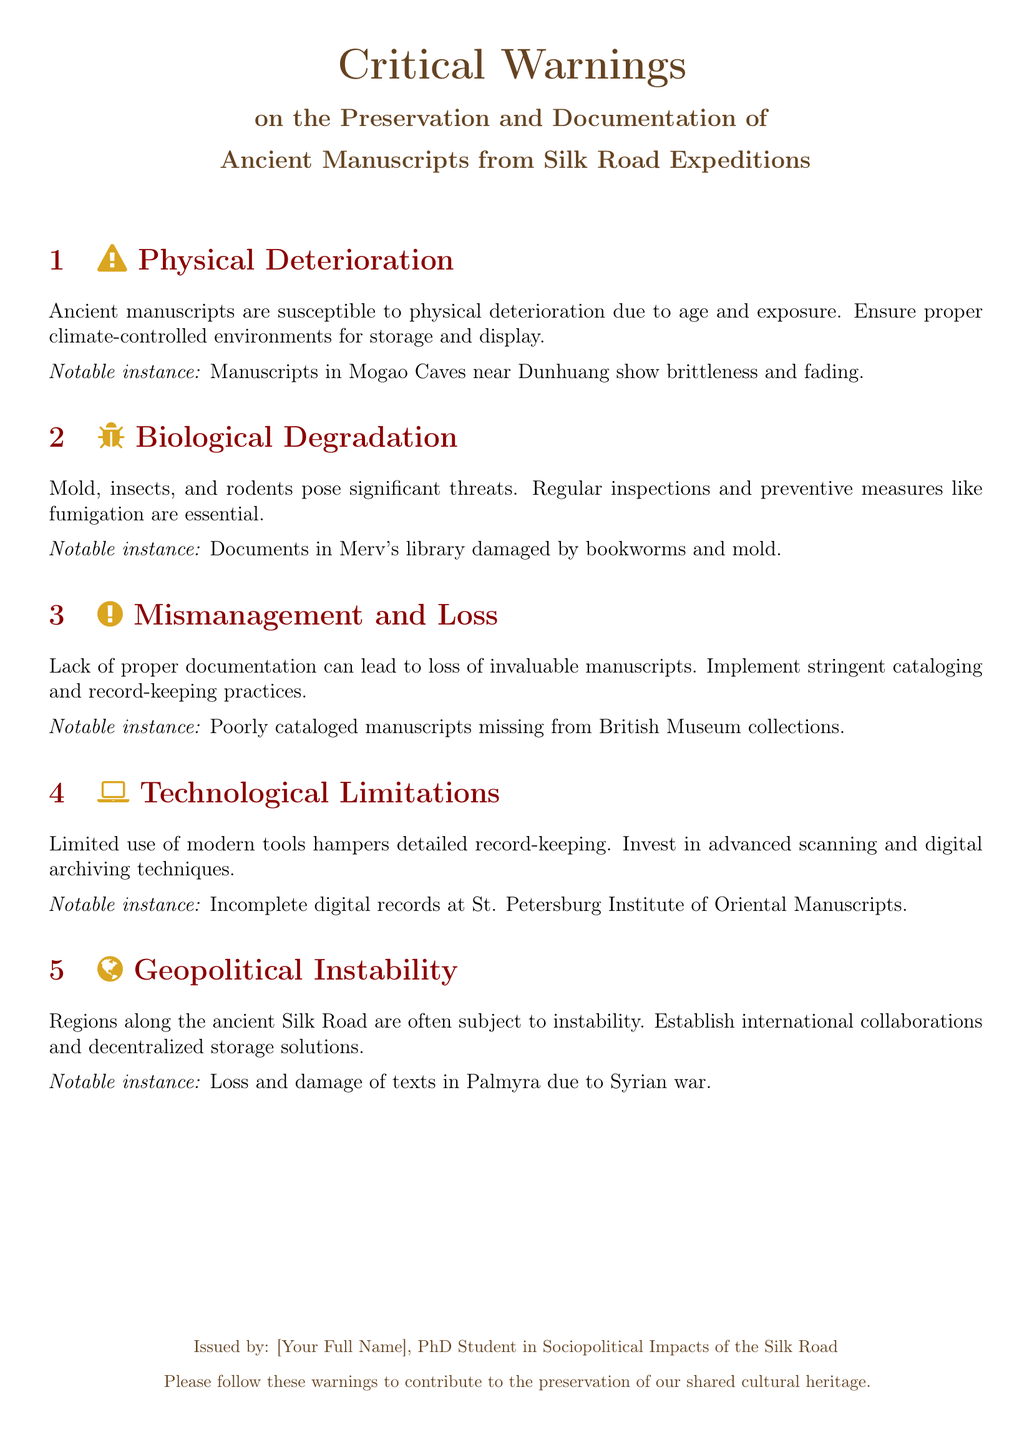What is the color associated with Physical Deterioration? The section color for Physical Deterioration is silk gold.
Answer: silk gold What notable instance is associated with Biological Degradation? The document mentions that documents in Merv's library were damaged by bookworms and mold.
Answer: documents in Merv's library How many critical warnings are listed in the document? There are five critical warnings detailed in the document.
Answer: five What preventative measure is suggested against Biological Degradation? Regular inspections and preventive measures like fumigation are recommended.
Answer: fumigation Which geopolitical issue is mentioned in the context of manuscript preservation? The document highlights that regions along the Silk Road face geopolitical instability.
Answer: geopolitical instability What is the recommended practice for managing manuscripts? Implement stringent cataloging and record-keeping practices is advised.
Answer: cataloging and record-keeping What technological limitation is discussed in the document? Limited use of modern tools is identified as a hindrance to proper record-keeping.
Answer: modern tools Who is the document issued by? The document is issued by a PhD student in Sociopolitical Impacts of the Silk Road.
Answer: [Your Full Name] 